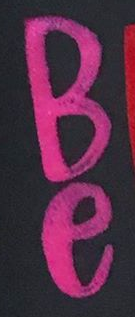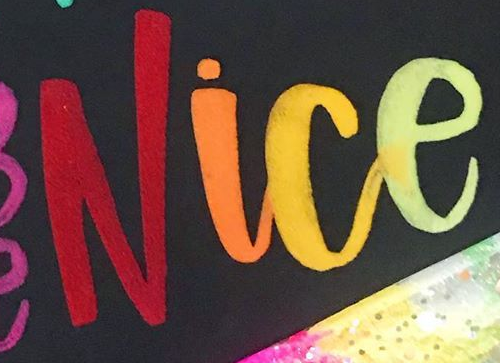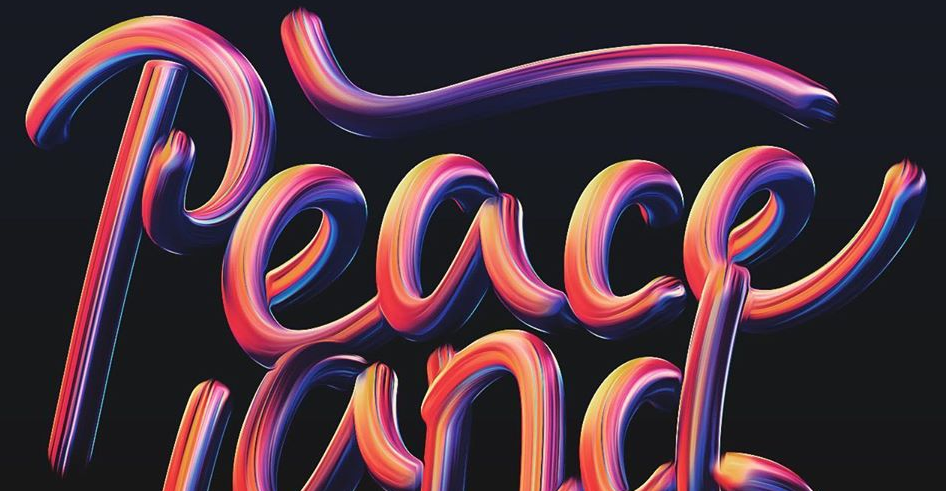Identify the words shown in these images in order, separated by a semicolon. Be; Nice; Peace 